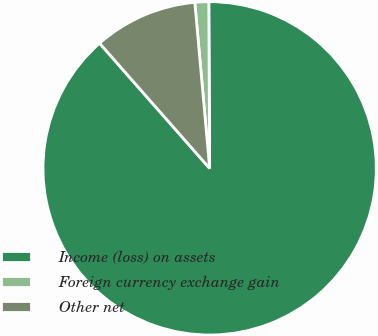<chart> <loc_0><loc_0><loc_500><loc_500><pie_chart><fcel>Income (loss) on assets<fcel>Foreign currency exchange gain<fcel>Other net<nl><fcel>88.6%<fcel>1.34%<fcel>10.06%<nl></chart> 